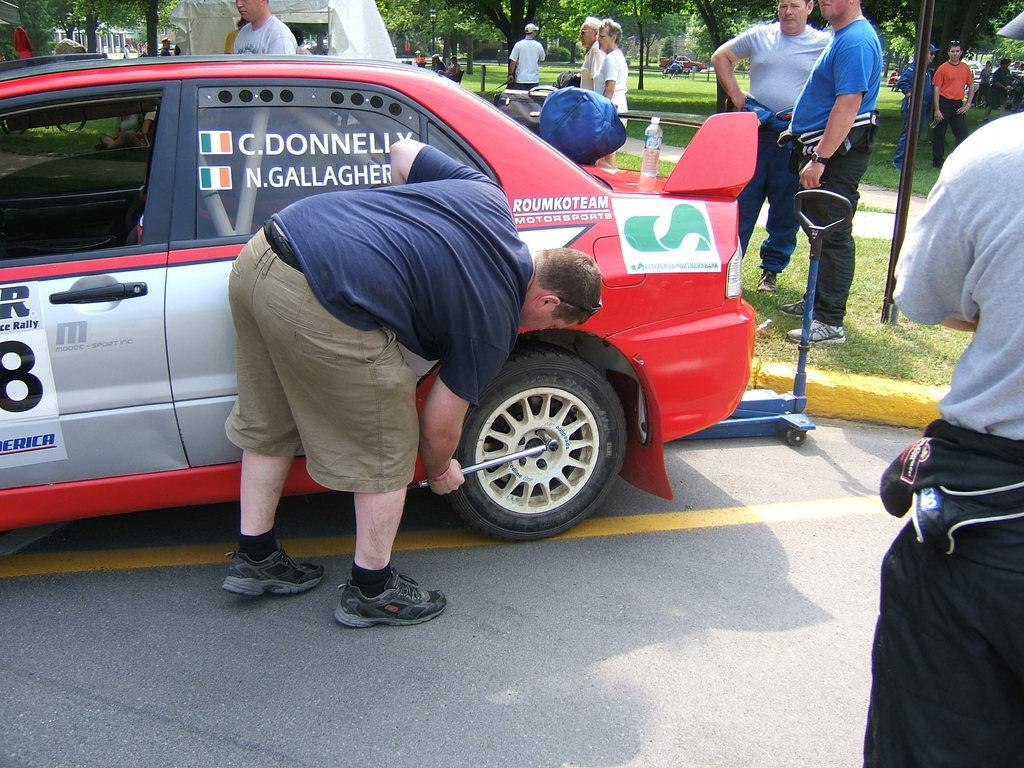Where was the image taken? The image was taken outside. What is the main subject in the middle of the image? There is a red car in the middle of the image. Are there any people present in the image? Yes, there are multiple persons in the middle of the image. What type of natural scenery is visible at the top of the image? There are trees visible at the top of the image. Can you see a stream flowing in front of the red car in the image? There is no stream visible in the image, and the red car is not in front of any stream. Is there a cat sitting on the roof of the red car in the image? There is no cat present in the image, and therefore no cat can be seen on the roof of the red car. 